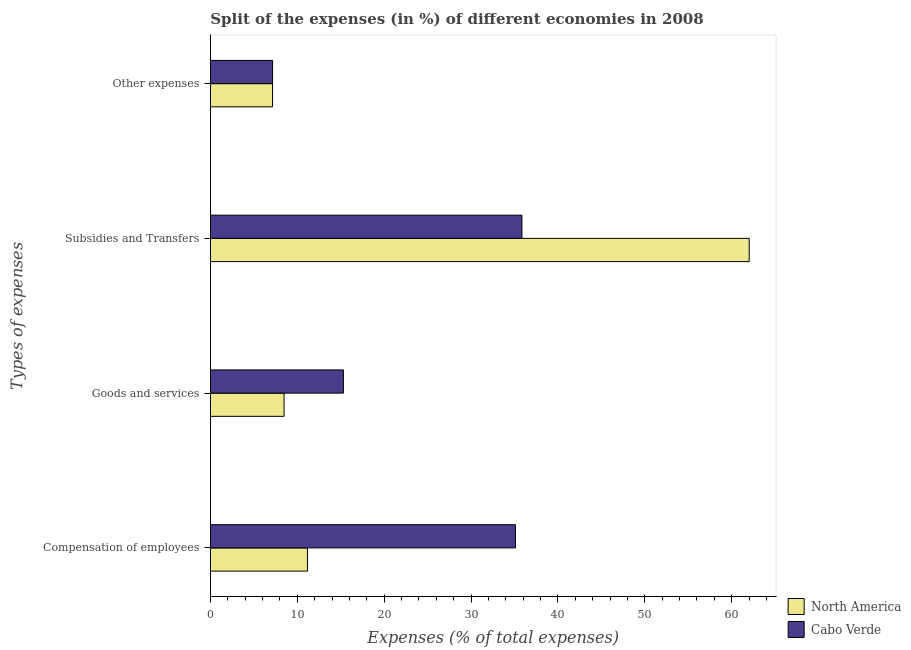How many different coloured bars are there?
Your answer should be very brief. 2. Are the number of bars per tick equal to the number of legend labels?
Give a very brief answer. Yes. What is the label of the 3rd group of bars from the top?
Your response must be concise. Goods and services. What is the percentage of amount spent on other expenses in North America?
Offer a very short reply. 7.15. Across all countries, what is the maximum percentage of amount spent on subsidies?
Your response must be concise. 62.01. Across all countries, what is the minimum percentage of amount spent on goods and services?
Your answer should be compact. 8.48. In which country was the percentage of amount spent on subsidies maximum?
Your answer should be compact. North America. In which country was the percentage of amount spent on compensation of employees minimum?
Give a very brief answer. North America. What is the total percentage of amount spent on subsidies in the graph?
Your response must be concise. 97.87. What is the difference between the percentage of amount spent on goods and services in North America and that in Cabo Verde?
Keep it short and to the point. -6.83. What is the difference between the percentage of amount spent on other expenses in North America and the percentage of amount spent on goods and services in Cabo Verde?
Your answer should be compact. -8.16. What is the average percentage of amount spent on other expenses per country?
Keep it short and to the point. 7.16. What is the difference between the percentage of amount spent on subsidies and percentage of amount spent on goods and services in Cabo Verde?
Make the answer very short. 20.55. In how many countries, is the percentage of amount spent on goods and services greater than 48 %?
Your response must be concise. 0. What is the ratio of the percentage of amount spent on other expenses in North America to that in Cabo Verde?
Offer a terse response. 1. Is the percentage of amount spent on compensation of employees in North America less than that in Cabo Verde?
Ensure brevity in your answer.  Yes. Is the difference between the percentage of amount spent on goods and services in North America and Cabo Verde greater than the difference between the percentage of amount spent on other expenses in North America and Cabo Verde?
Offer a terse response. No. What is the difference between the highest and the second highest percentage of amount spent on other expenses?
Offer a very short reply. 0. What is the difference between the highest and the lowest percentage of amount spent on other expenses?
Your answer should be very brief. 0. Is it the case that in every country, the sum of the percentage of amount spent on compensation of employees and percentage of amount spent on goods and services is greater than the percentage of amount spent on subsidies?
Keep it short and to the point. No. How many bars are there?
Give a very brief answer. 8. Are all the bars in the graph horizontal?
Give a very brief answer. Yes. How many countries are there in the graph?
Make the answer very short. 2. Does the graph contain any zero values?
Offer a very short reply. No. Does the graph contain grids?
Your answer should be very brief. No. Where does the legend appear in the graph?
Ensure brevity in your answer.  Bottom right. How many legend labels are there?
Provide a short and direct response. 2. What is the title of the graph?
Give a very brief answer. Split of the expenses (in %) of different economies in 2008. Does "Cyprus" appear as one of the legend labels in the graph?
Offer a very short reply. No. What is the label or title of the X-axis?
Provide a succinct answer. Expenses (% of total expenses). What is the label or title of the Y-axis?
Your response must be concise. Types of expenses. What is the Expenses (% of total expenses) in North America in Compensation of employees?
Provide a succinct answer. 11.17. What is the Expenses (% of total expenses) of Cabo Verde in Compensation of employees?
Your answer should be very brief. 35.11. What is the Expenses (% of total expenses) in North America in Goods and services?
Offer a very short reply. 8.48. What is the Expenses (% of total expenses) of Cabo Verde in Goods and services?
Keep it short and to the point. 15.31. What is the Expenses (% of total expenses) in North America in Subsidies and Transfers?
Offer a very short reply. 62.01. What is the Expenses (% of total expenses) of Cabo Verde in Subsidies and Transfers?
Keep it short and to the point. 35.86. What is the Expenses (% of total expenses) in North America in Other expenses?
Ensure brevity in your answer.  7.15. What is the Expenses (% of total expenses) in Cabo Verde in Other expenses?
Your answer should be very brief. 7.16. Across all Types of expenses, what is the maximum Expenses (% of total expenses) in North America?
Your answer should be very brief. 62.01. Across all Types of expenses, what is the maximum Expenses (% of total expenses) in Cabo Verde?
Your response must be concise. 35.86. Across all Types of expenses, what is the minimum Expenses (% of total expenses) in North America?
Offer a very short reply. 7.15. Across all Types of expenses, what is the minimum Expenses (% of total expenses) in Cabo Verde?
Keep it short and to the point. 7.16. What is the total Expenses (% of total expenses) in North America in the graph?
Your answer should be very brief. 88.82. What is the total Expenses (% of total expenses) of Cabo Verde in the graph?
Provide a succinct answer. 93.44. What is the difference between the Expenses (% of total expenses) of North America in Compensation of employees and that in Goods and services?
Make the answer very short. 2.69. What is the difference between the Expenses (% of total expenses) in Cabo Verde in Compensation of employees and that in Goods and services?
Make the answer very short. 19.81. What is the difference between the Expenses (% of total expenses) in North America in Compensation of employees and that in Subsidies and Transfers?
Your response must be concise. -50.84. What is the difference between the Expenses (% of total expenses) in Cabo Verde in Compensation of employees and that in Subsidies and Transfers?
Your answer should be compact. -0.74. What is the difference between the Expenses (% of total expenses) in North America in Compensation of employees and that in Other expenses?
Provide a short and direct response. 4.02. What is the difference between the Expenses (% of total expenses) of Cabo Verde in Compensation of employees and that in Other expenses?
Provide a short and direct response. 27.96. What is the difference between the Expenses (% of total expenses) of North America in Goods and services and that in Subsidies and Transfers?
Your response must be concise. -53.54. What is the difference between the Expenses (% of total expenses) in Cabo Verde in Goods and services and that in Subsidies and Transfers?
Offer a very short reply. -20.55. What is the difference between the Expenses (% of total expenses) in North America in Goods and services and that in Other expenses?
Ensure brevity in your answer.  1.33. What is the difference between the Expenses (% of total expenses) in Cabo Verde in Goods and services and that in Other expenses?
Provide a succinct answer. 8.15. What is the difference between the Expenses (% of total expenses) of North America in Subsidies and Transfers and that in Other expenses?
Offer a very short reply. 54.86. What is the difference between the Expenses (% of total expenses) in Cabo Verde in Subsidies and Transfers and that in Other expenses?
Keep it short and to the point. 28.7. What is the difference between the Expenses (% of total expenses) in North America in Compensation of employees and the Expenses (% of total expenses) in Cabo Verde in Goods and services?
Provide a short and direct response. -4.14. What is the difference between the Expenses (% of total expenses) in North America in Compensation of employees and the Expenses (% of total expenses) in Cabo Verde in Subsidies and Transfers?
Ensure brevity in your answer.  -24.69. What is the difference between the Expenses (% of total expenses) in North America in Compensation of employees and the Expenses (% of total expenses) in Cabo Verde in Other expenses?
Ensure brevity in your answer.  4.01. What is the difference between the Expenses (% of total expenses) in North America in Goods and services and the Expenses (% of total expenses) in Cabo Verde in Subsidies and Transfers?
Provide a succinct answer. -27.38. What is the difference between the Expenses (% of total expenses) in North America in Goods and services and the Expenses (% of total expenses) in Cabo Verde in Other expenses?
Offer a very short reply. 1.32. What is the difference between the Expenses (% of total expenses) of North America in Subsidies and Transfers and the Expenses (% of total expenses) of Cabo Verde in Other expenses?
Give a very brief answer. 54.86. What is the average Expenses (% of total expenses) in North America per Types of expenses?
Provide a short and direct response. 22.2. What is the average Expenses (% of total expenses) of Cabo Verde per Types of expenses?
Your response must be concise. 23.36. What is the difference between the Expenses (% of total expenses) of North America and Expenses (% of total expenses) of Cabo Verde in Compensation of employees?
Make the answer very short. -23.94. What is the difference between the Expenses (% of total expenses) of North America and Expenses (% of total expenses) of Cabo Verde in Goods and services?
Ensure brevity in your answer.  -6.83. What is the difference between the Expenses (% of total expenses) of North America and Expenses (% of total expenses) of Cabo Verde in Subsidies and Transfers?
Provide a short and direct response. 26.16. What is the difference between the Expenses (% of total expenses) of North America and Expenses (% of total expenses) of Cabo Verde in Other expenses?
Your answer should be compact. -0. What is the ratio of the Expenses (% of total expenses) in North America in Compensation of employees to that in Goods and services?
Your answer should be compact. 1.32. What is the ratio of the Expenses (% of total expenses) in Cabo Verde in Compensation of employees to that in Goods and services?
Keep it short and to the point. 2.29. What is the ratio of the Expenses (% of total expenses) of North America in Compensation of employees to that in Subsidies and Transfers?
Give a very brief answer. 0.18. What is the ratio of the Expenses (% of total expenses) of Cabo Verde in Compensation of employees to that in Subsidies and Transfers?
Provide a succinct answer. 0.98. What is the ratio of the Expenses (% of total expenses) of North America in Compensation of employees to that in Other expenses?
Offer a very short reply. 1.56. What is the ratio of the Expenses (% of total expenses) of Cabo Verde in Compensation of employees to that in Other expenses?
Your answer should be very brief. 4.91. What is the ratio of the Expenses (% of total expenses) of North America in Goods and services to that in Subsidies and Transfers?
Your answer should be very brief. 0.14. What is the ratio of the Expenses (% of total expenses) of Cabo Verde in Goods and services to that in Subsidies and Transfers?
Provide a short and direct response. 0.43. What is the ratio of the Expenses (% of total expenses) in North America in Goods and services to that in Other expenses?
Offer a very short reply. 1.19. What is the ratio of the Expenses (% of total expenses) in Cabo Verde in Goods and services to that in Other expenses?
Your response must be concise. 2.14. What is the ratio of the Expenses (% of total expenses) in North America in Subsidies and Transfers to that in Other expenses?
Your answer should be very brief. 8.67. What is the ratio of the Expenses (% of total expenses) of Cabo Verde in Subsidies and Transfers to that in Other expenses?
Ensure brevity in your answer.  5.01. What is the difference between the highest and the second highest Expenses (% of total expenses) of North America?
Provide a succinct answer. 50.84. What is the difference between the highest and the second highest Expenses (% of total expenses) in Cabo Verde?
Keep it short and to the point. 0.74. What is the difference between the highest and the lowest Expenses (% of total expenses) in North America?
Offer a terse response. 54.86. What is the difference between the highest and the lowest Expenses (% of total expenses) in Cabo Verde?
Give a very brief answer. 28.7. 